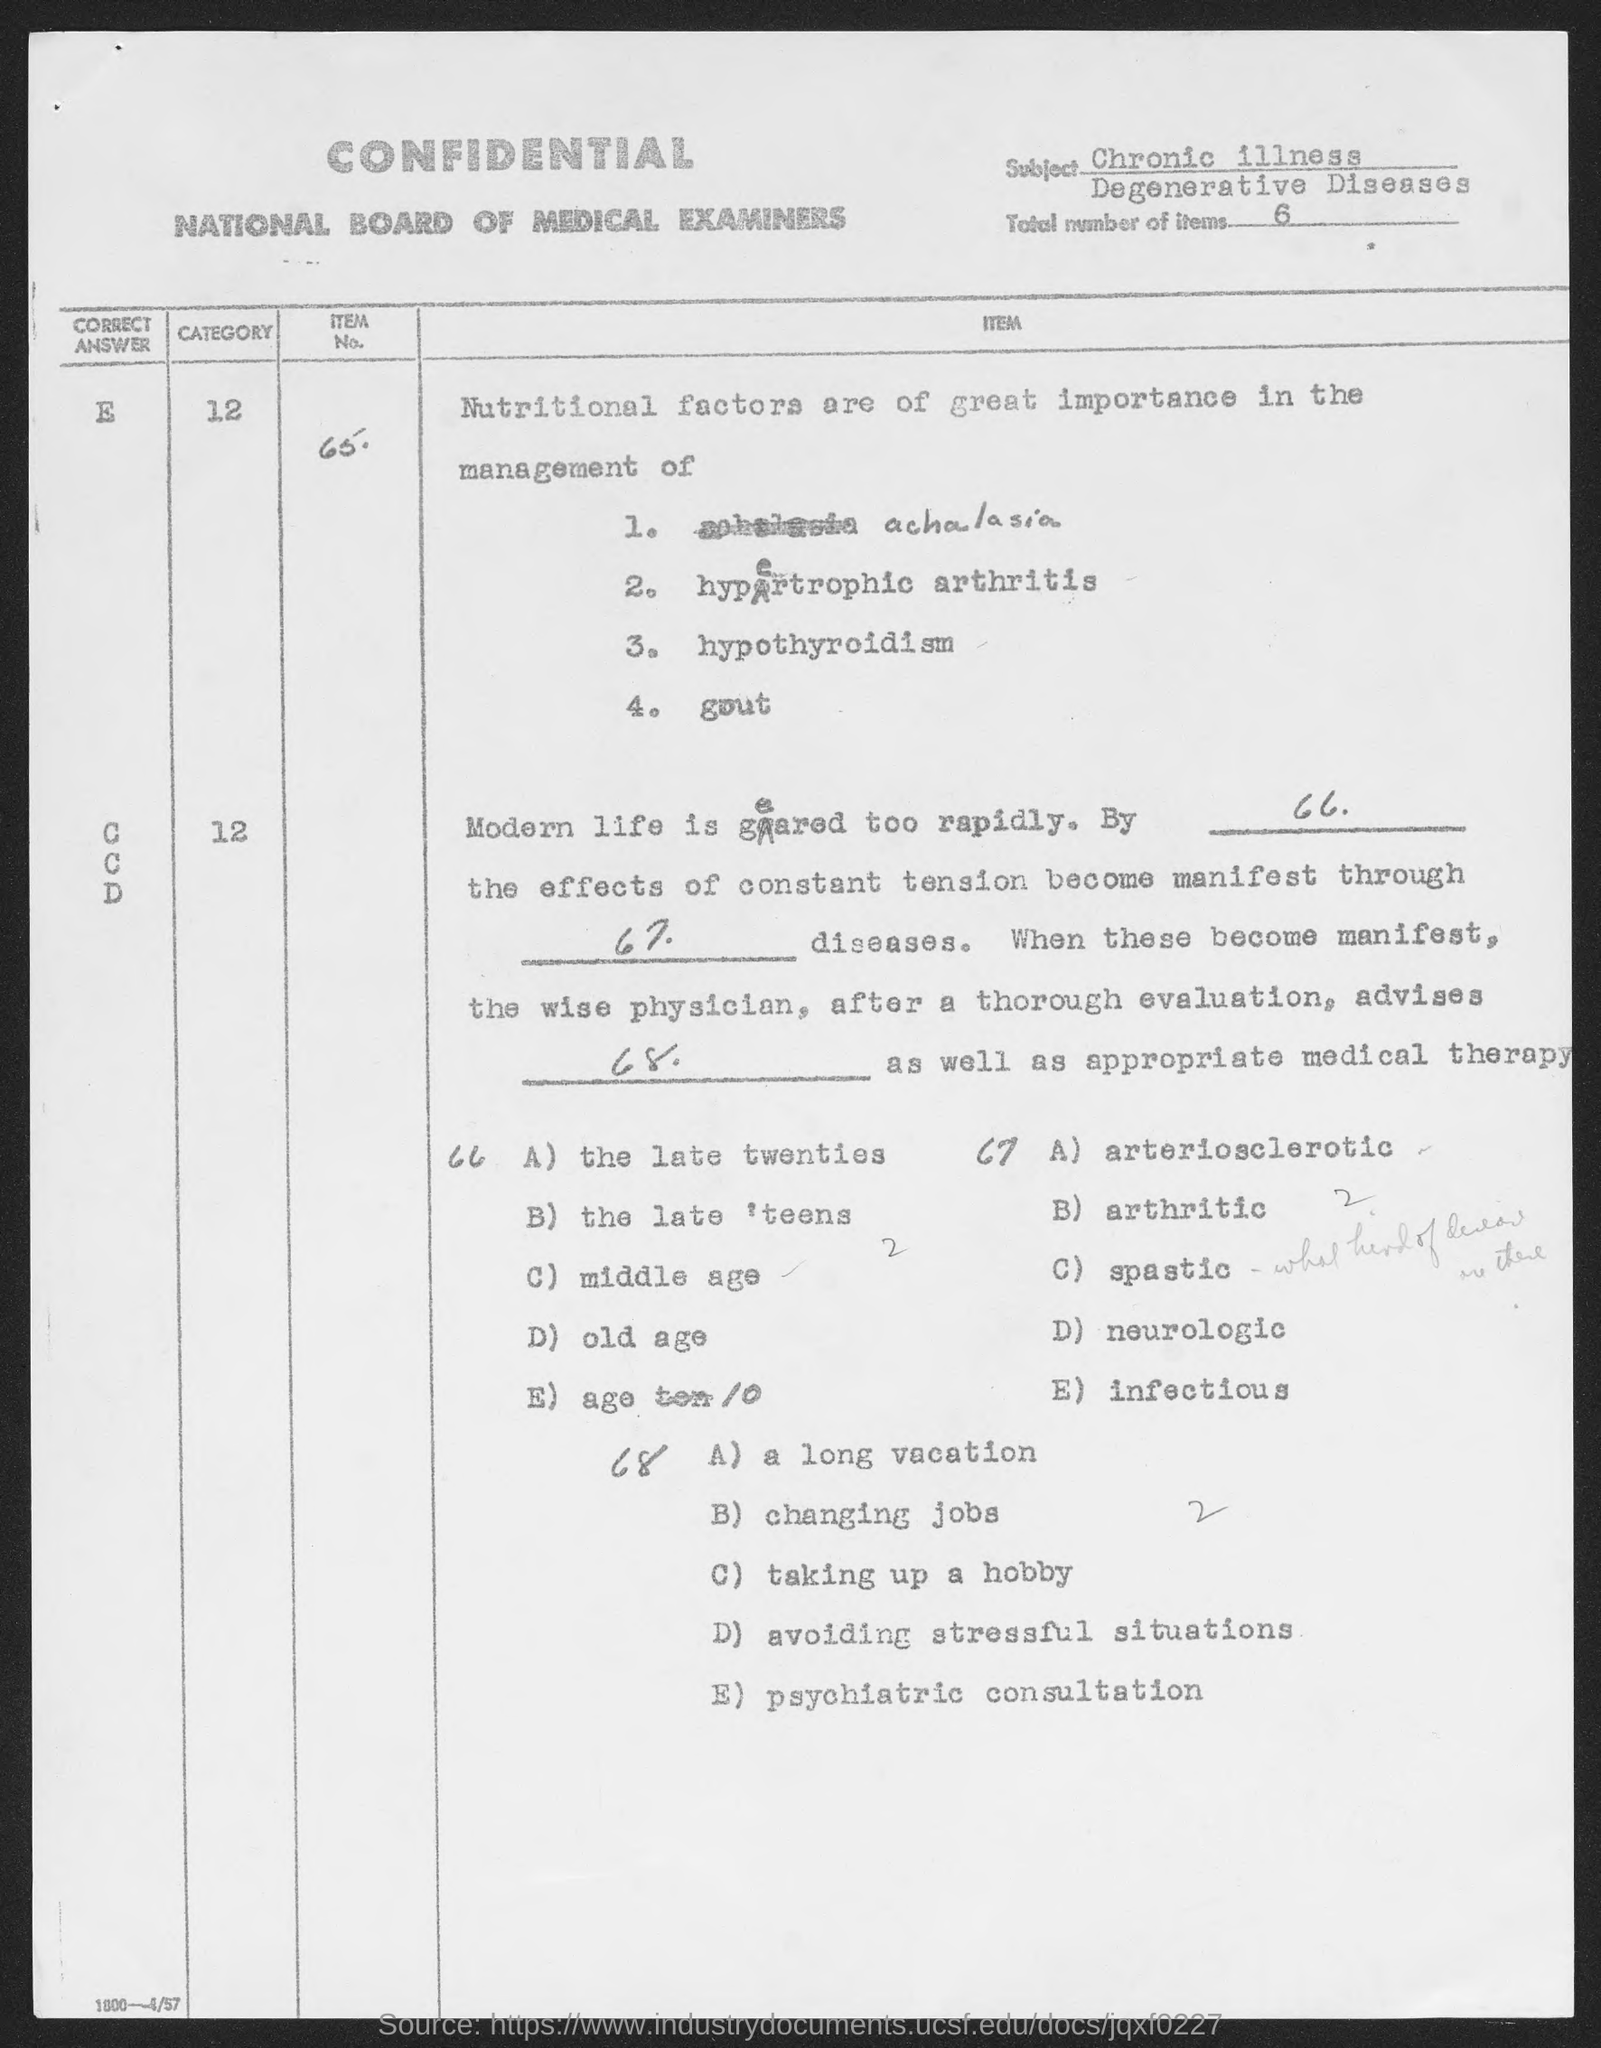Point out several critical features in this image. The total number of items is 6. The subject of the sentence is "Chronic Illness and Degenerative Diseases. 